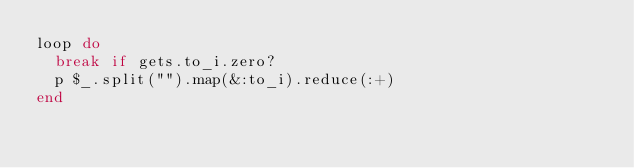<code> <loc_0><loc_0><loc_500><loc_500><_Ruby_>loop do
  break if gets.to_i.zero?
  p $_.split("").map(&:to_i).reduce(:+)
end</code> 